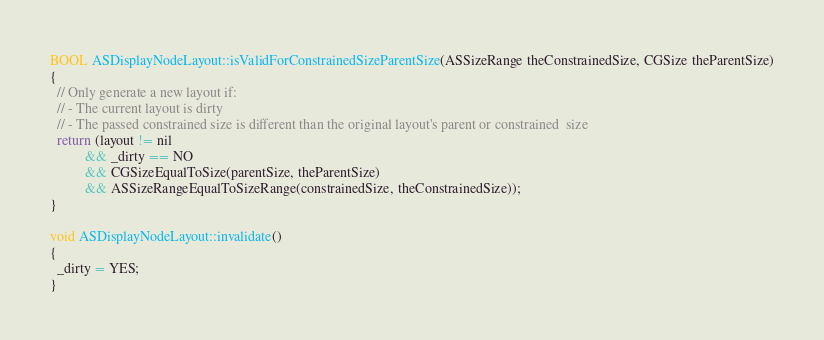<code> <loc_0><loc_0><loc_500><loc_500><_ObjectiveC_>BOOL ASDisplayNodeLayout::isValidForConstrainedSizeParentSize(ASSizeRange theConstrainedSize, CGSize theParentSize)
{
  // Only generate a new layout if:
  // - The current layout is dirty
  // - The passed constrained size is different than the original layout's parent or constrained  size
  return (layout != nil
          && _dirty == NO
          && CGSizeEqualToSize(parentSize, theParentSize)
          && ASSizeRangeEqualToSizeRange(constrainedSize, theConstrainedSize));
}

void ASDisplayNodeLayout::invalidate()
{
  _dirty = YES;
}
</code> 